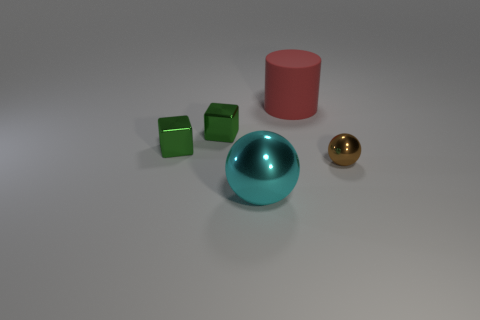What color is the large object left of the big rubber object that is to the right of the cyan shiny object? The large object to the left of the pink cylinder, which is situated to the right of the cyan shiny sphere, appears to be a pair of green cubes. 